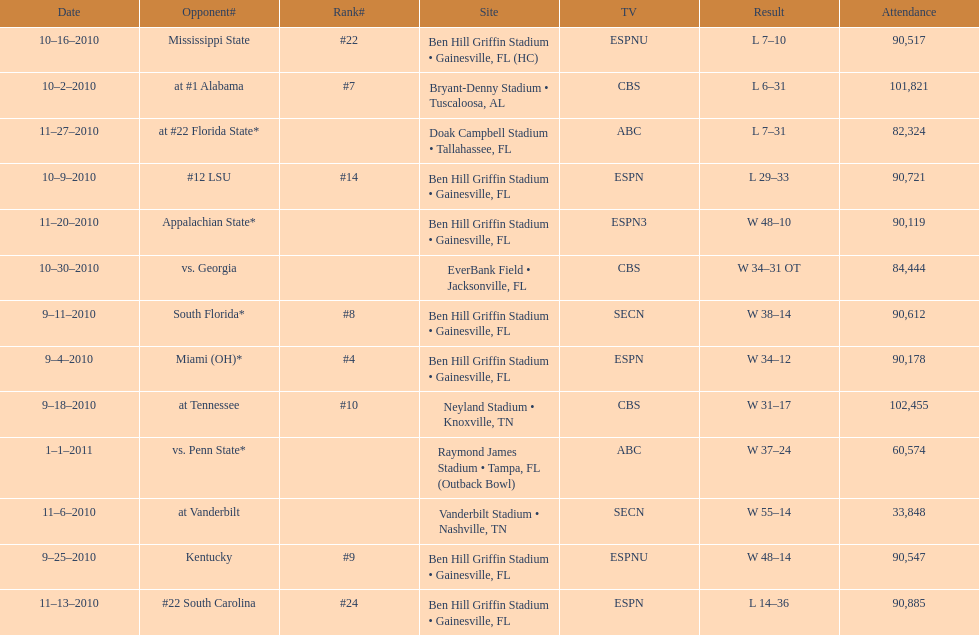The gators won the game on september 25, 2010. who won the previous game? Gators. 